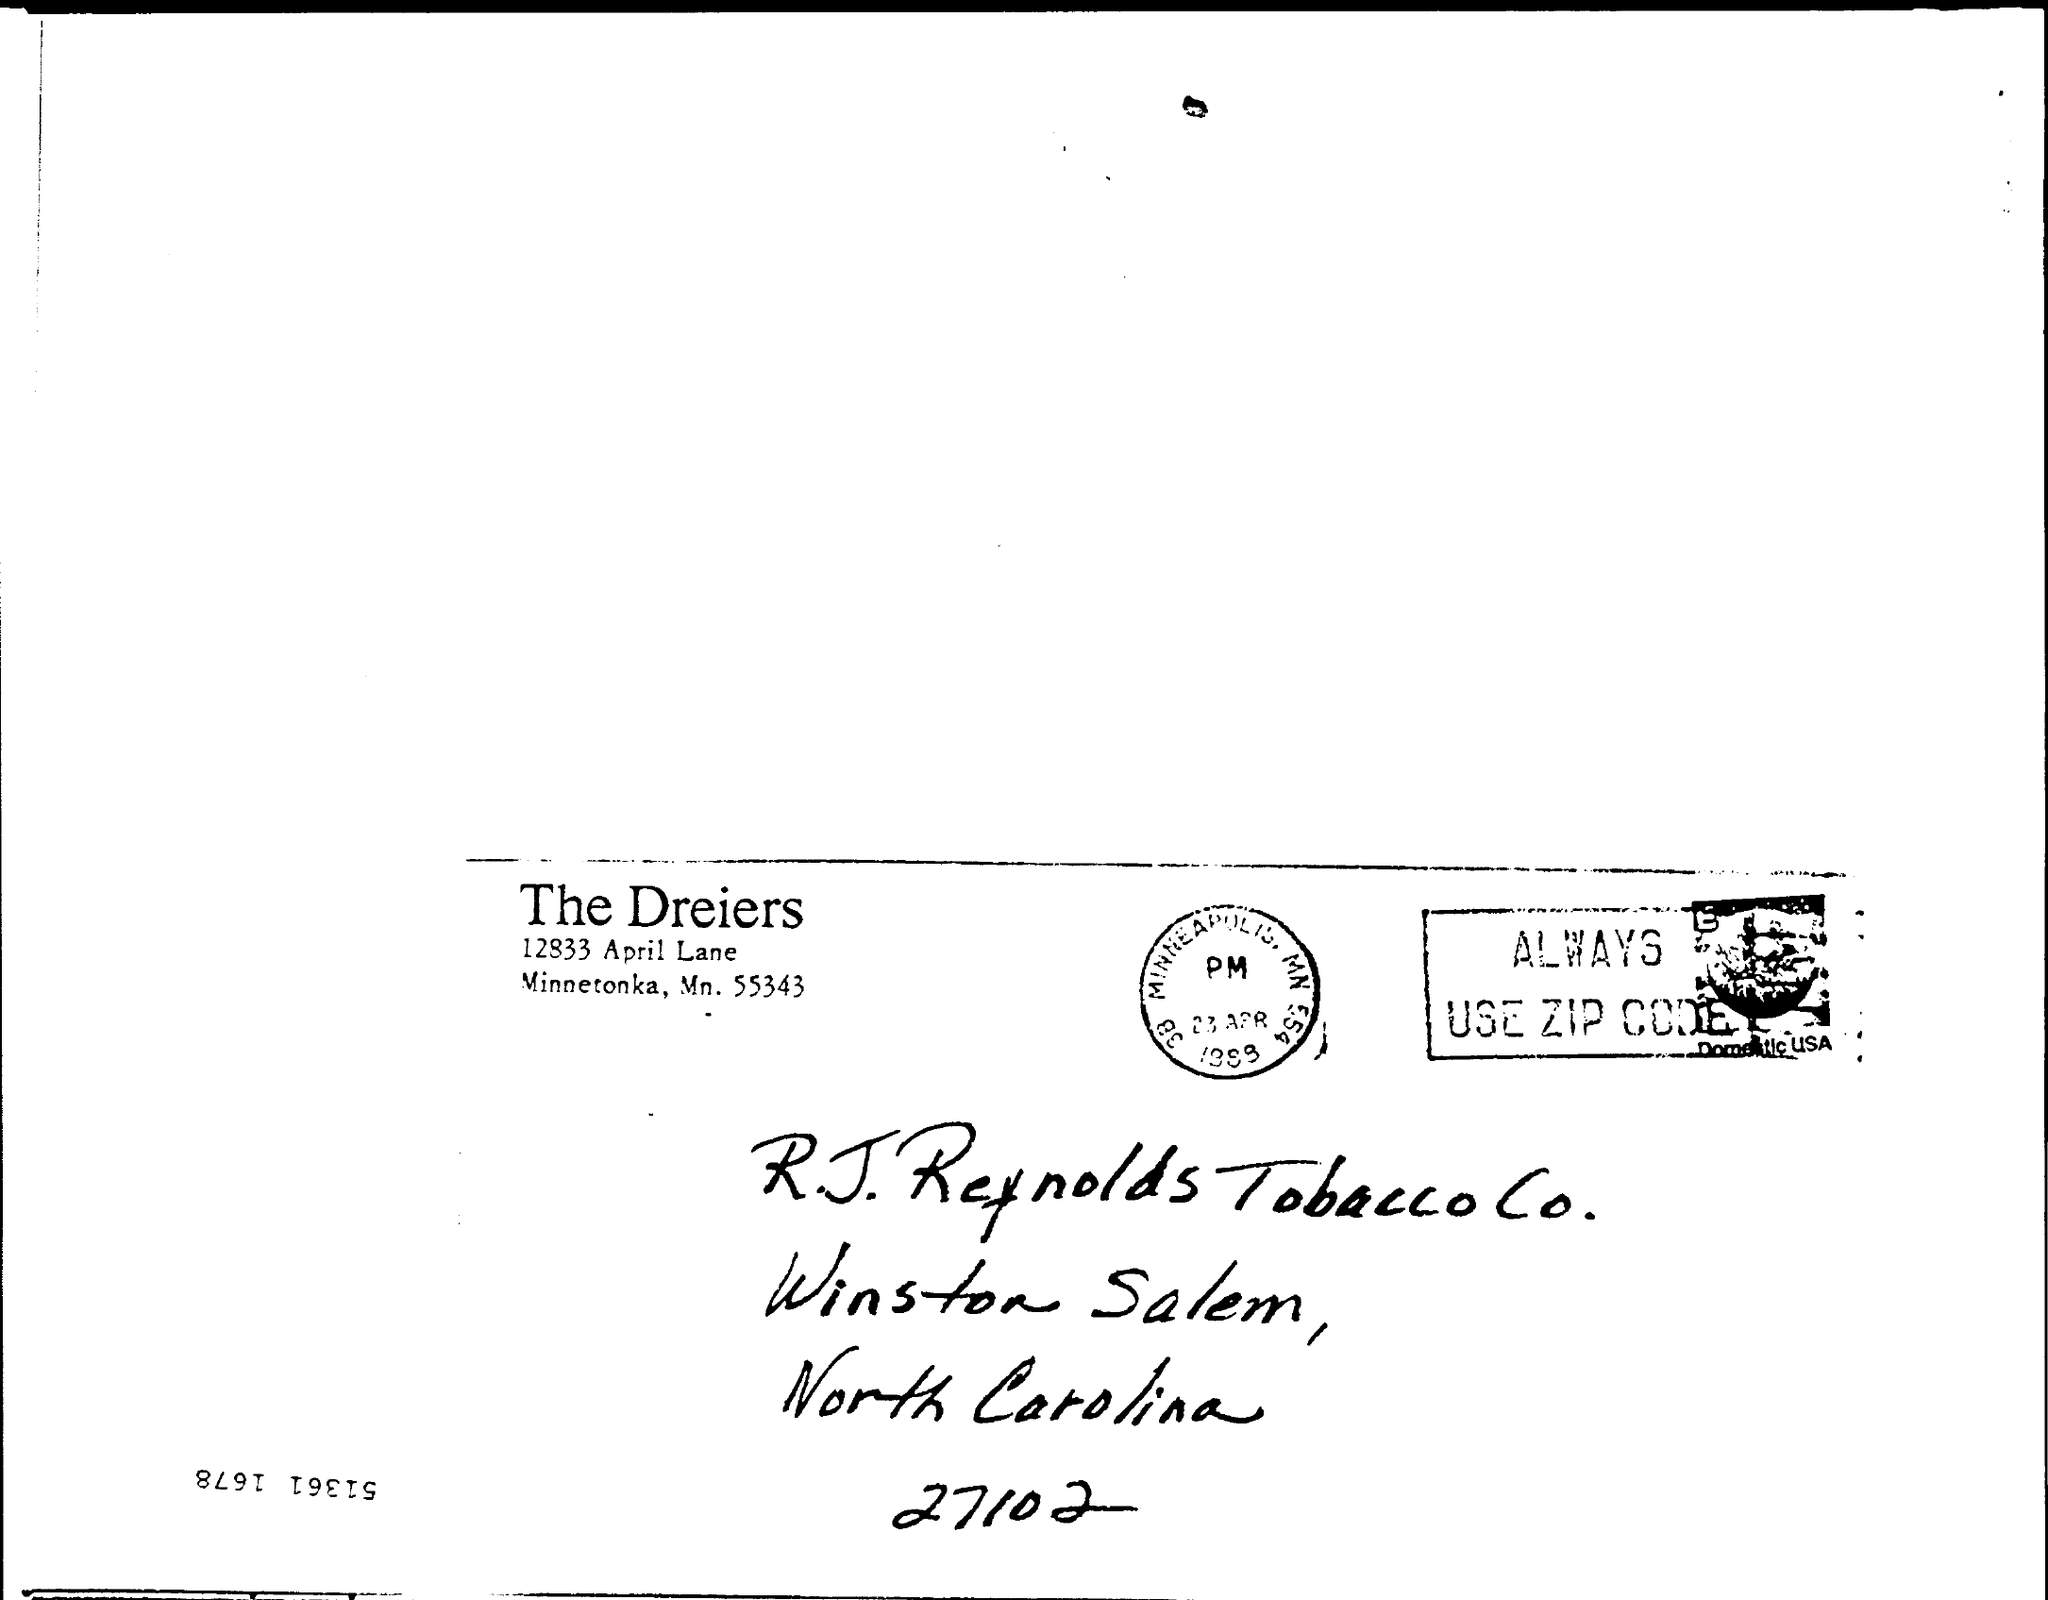From whom is the letter?
Offer a terse response. The Dreiers. What is the zip code of R. J. Reynolds Tobacco Co.?
Provide a short and direct response. 27102. 